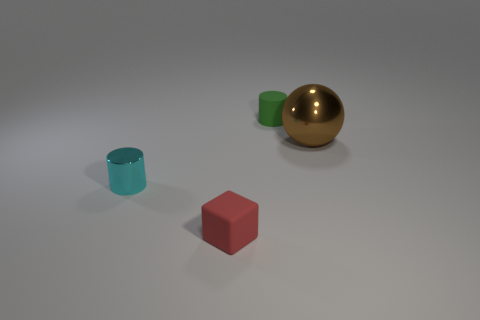What is the texture of the objects presented in the image? While I cannot physically touch the objects, based on their appearance, the cylinders and cube seem to have a matte or slightly satiny texture. The metallic sphere, on the other hand, has a reflective, shiny surface that suggests a smooth texture. 